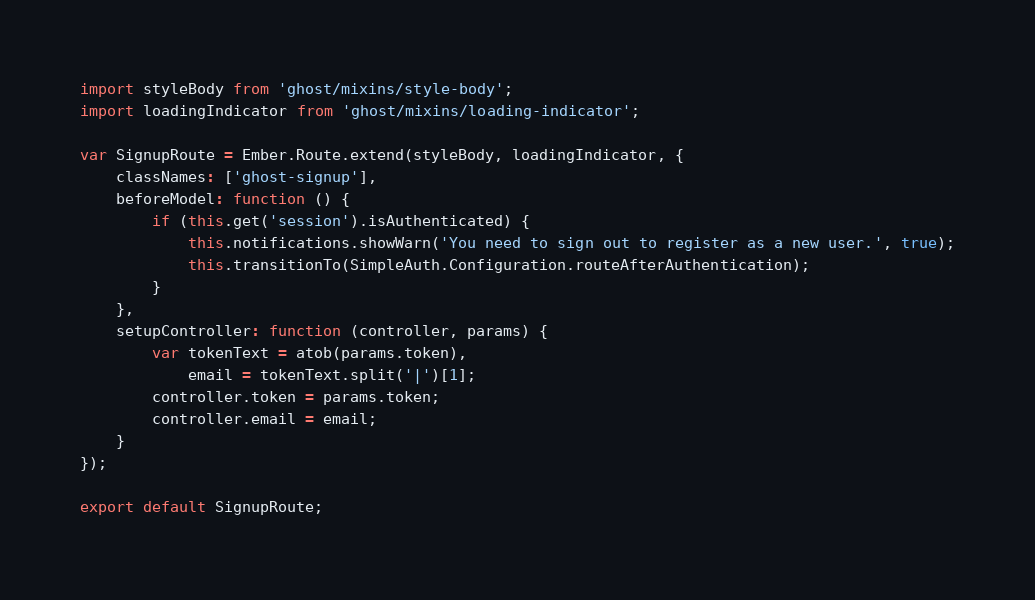Convert code to text. <code><loc_0><loc_0><loc_500><loc_500><_JavaScript_>import styleBody from 'ghost/mixins/style-body';
import loadingIndicator from 'ghost/mixins/loading-indicator';

var SignupRoute = Ember.Route.extend(styleBody, loadingIndicator, {
    classNames: ['ghost-signup'],
    beforeModel: function () {
        if (this.get('session').isAuthenticated) {
            this.notifications.showWarn('You need to sign out to register as a new user.', true);
            this.transitionTo(SimpleAuth.Configuration.routeAfterAuthentication);
        }
    },
    setupController: function (controller, params) {
        var tokenText = atob(params.token),
            email = tokenText.split('|')[1];
        controller.token = params.token;
        controller.email = email;
    }
});

export default SignupRoute;
</code> 